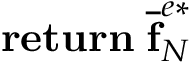Convert formula to latex. <formula><loc_0><loc_0><loc_500><loc_500>r e t u r n \, \overline { f } _ { N } ^ { e * }</formula> 